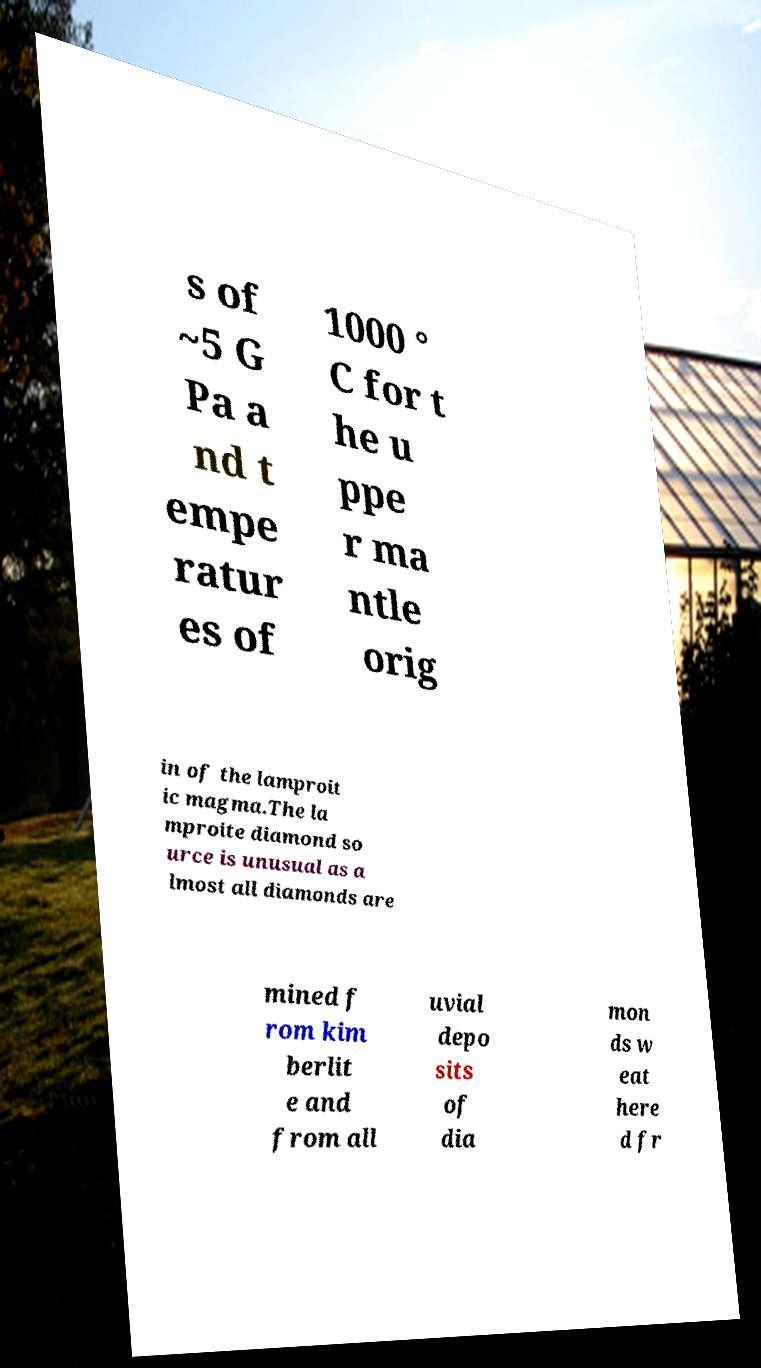Could you assist in decoding the text presented in this image and type it out clearly? s of ~5 G Pa a nd t empe ratur es of 1000 ° C for t he u ppe r ma ntle orig in of the lamproit ic magma.The la mproite diamond so urce is unusual as a lmost all diamonds are mined f rom kim berlit e and from all uvial depo sits of dia mon ds w eat here d fr 